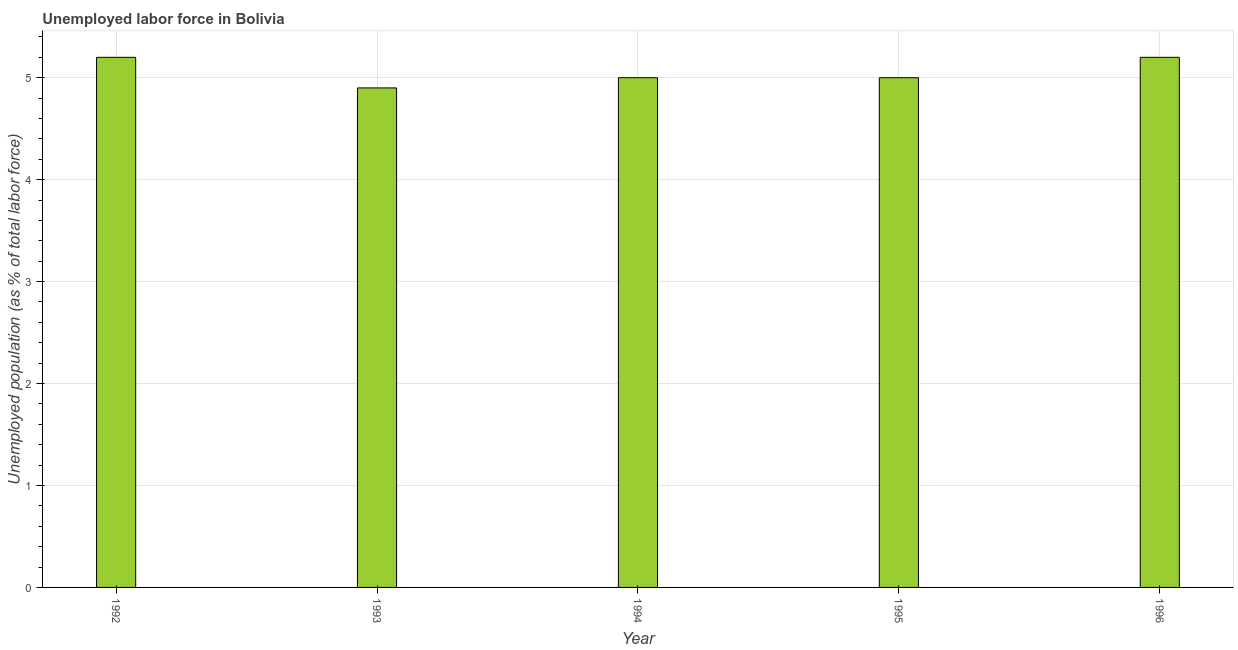Does the graph contain any zero values?
Provide a succinct answer. No. What is the title of the graph?
Provide a succinct answer. Unemployed labor force in Bolivia. What is the label or title of the X-axis?
Your answer should be very brief. Year. What is the label or title of the Y-axis?
Your answer should be compact. Unemployed population (as % of total labor force). What is the total unemployed population in 1992?
Your answer should be compact. 5.2. Across all years, what is the maximum total unemployed population?
Provide a succinct answer. 5.2. Across all years, what is the minimum total unemployed population?
Offer a terse response. 4.9. In which year was the total unemployed population maximum?
Offer a terse response. 1992. In which year was the total unemployed population minimum?
Make the answer very short. 1993. What is the sum of the total unemployed population?
Offer a terse response. 25.3. What is the average total unemployed population per year?
Keep it short and to the point. 5.06. In how many years, is the total unemployed population greater than 3.6 %?
Give a very brief answer. 5. What is the ratio of the total unemployed population in 1992 to that in 1993?
Ensure brevity in your answer.  1.06. What is the difference between the highest and the second highest total unemployed population?
Ensure brevity in your answer.  0. In how many years, is the total unemployed population greater than the average total unemployed population taken over all years?
Ensure brevity in your answer.  2. How many bars are there?
Make the answer very short. 5. How many years are there in the graph?
Provide a succinct answer. 5. What is the difference between two consecutive major ticks on the Y-axis?
Ensure brevity in your answer.  1. Are the values on the major ticks of Y-axis written in scientific E-notation?
Give a very brief answer. No. What is the Unemployed population (as % of total labor force) of 1992?
Offer a very short reply. 5.2. What is the Unemployed population (as % of total labor force) of 1993?
Offer a terse response. 4.9. What is the Unemployed population (as % of total labor force) of 1994?
Ensure brevity in your answer.  5. What is the Unemployed population (as % of total labor force) in 1996?
Provide a short and direct response. 5.2. What is the difference between the Unemployed population (as % of total labor force) in 1992 and 1993?
Your response must be concise. 0.3. What is the difference between the Unemployed population (as % of total labor force) in 1992 and 1994?
Offer a very short reply. 0.2. What is the difference between the Unemployed population (as % of total labor force) in 1992 and 1995?
Ensure brevity in your answer.  0.2. What is the difference between the Unemployed population (as % of total labor force) in 1995 and 1996?
Ensure brevity in your answer.  -0.2. What is the ratio of the Unemployed population (as % of total labor force) in 1992 to that in 1993?
Your answer should be compact. 1.06. What is the ratio of the Unemployed population (as % of total labor force) in 1992 to that in 1994?
Provide a short and direct response. 1.04. What is the ratio of the Unemployed population (as % of total labor force) in 1992 to that in 1995?
Your answer should be very brief. 1.04. What is the ratio of the Unemployed population (as % of total labor force) in 1993 to that in 1994?
Make the answer very short. 0.98. What is the ratio of the Unemployed population (as % of total labor force) in 1993 to that in 1995?
Your response must be concise. 0.98. What is the ratio of the Unemployed population (as % of total labor force) in 1993 to that in 1996?
Give a very brief answer. 0.94. What is the ratio of the Unemployed population (as % of total labor force) in 1994 to that in 1996?
Make the answer very short. 0.96. 